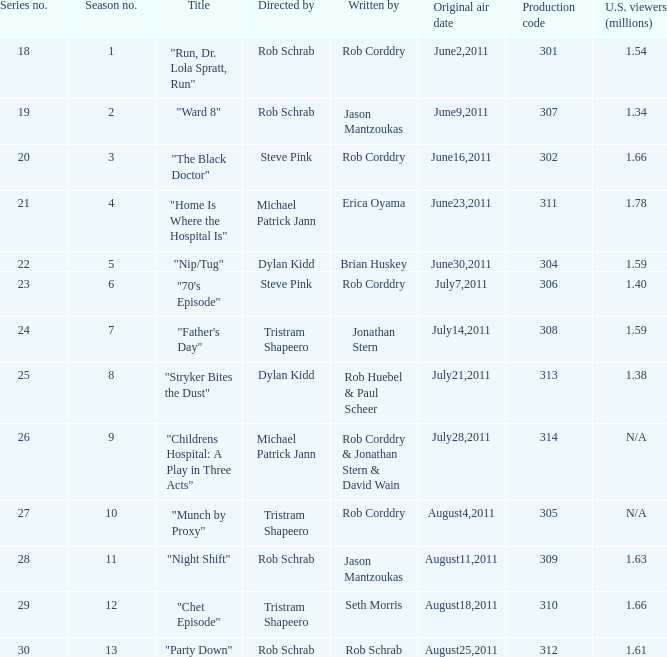At most what number in the series was the episode "chet episode"? 29.0. 